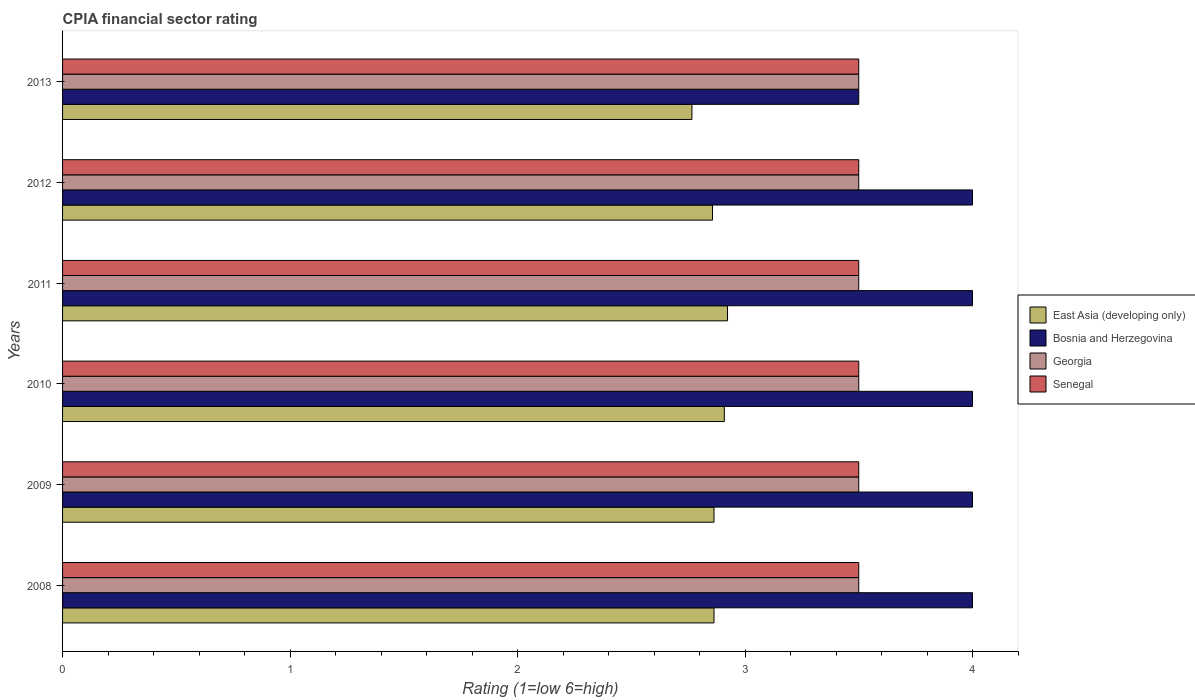How many different coloured bars are there?
Offer a terse response. 4. How many bars are there on the 1st tick from the top?
Your answer should be very brief. 4. How many bars are there on the 2nd tick from the bottom?
Make the answer very short. 4. What is the label of the 3rd group of bars from the top?
Provide a short and direct response. 2011. In how many cases, is the number of bars for a given year not equal to the number of legend labels?
Your response must be concise. 0. What is the CPIA rating in East Asia (developing only) in 2012?
Offer a very short reply. 2.86. Across all years, what is the maximum CPIA rating in Senegal?
Keep it short and to the point. 3.5. Across all years, what is the minimum CPIA rating in Senegal?
Ensure brevity in your answer.  3.5. In which year was the CPIA rating in Georgia maximum?
Provide a succinct answer. 2008. What is the difference between the CPIA rating in Senegal in 2008 and that in 2009?
Offer a very short reply. 0. What is the difference between the CPIA rating in Senegal in 2009 and the CPIA rating in Bosnia and Herzegovina in 2013?
Offer a very short reply. 0. In the year 2010, what is the difference between the CPIA rating in East Asia (developing only) and CPIA rating in Senegal?
Ensure brevity in your answer.  -0.59. What is the difference between the highest and the second highest CPIA rating in East Asia (developing only)?
Offer a terse response. 0.01. Is it the case that in every year, the sum of the CPIA rating in Bosnia and Herzegovina and CPIA rating in Georgia is greater than the sum of CPIA rating in East Asia (developing only) and CPIA rating in Senegal?
Give a very brief answer. No. What does the 1st bar from the top in 2008 represents?
Offer a very short reply. Senegal. What does the 2nd bar from the bottom in 2011 represents?
Your response must be concise. Bosnia and Herzegovina. Is it the case that in every year, the sum of the CPIA rating in Georgia and CPIA rating in Senegal is greater than the CPIA rating in East Asia (developing only)?
Keep it short and to the point. Yes. Are all the bars in the graph horizontal?
Offer a terse response. Yes. What is the difference between two consecutive major ticks on the X-axis?
Your response must be concise. 1. Does the graph contain grids?
Provide a succinct answer. No. Where does the legend appear in the graph?
Keep it short and to the point. Center right. How many legend labels are there?
Give a very brief answer. 4. How are the legend labels stacked?
Keep it short and to the point. Vertical. What is the title of the graph?
Make the answer very short. CPIA financial sector rating. Does "Afghanistan" appear as one of the legend labels in the graph?
Offer a terse response. No. What is the label or title of the Y-axis?
Your response must be concise. Years. What is the Rating (1=low 6=high) in East Asia (developing only) in 2008?
Offer a very short reply. 2.86. What is the Rating (1=low 6=high) in Bosnia and Herzegovina in 2008?
Give a very brief answer. 4. What is the Rating (1=low 6=high) of Georgia in 2008?
Offer a very short reply. 3.5. What is the Rating (1=low 6=high) of Senegal in 2008?
Keep it short and to the point. 3.5. What is the Rating (1=low 6=high) of East Asia (developing only) in 2009?
Offer a very short reply. 2.86. What is the Rating (1=low 6=high) in Georgia in 2009?
Offer a terse response. 3.5. What is the Rating (1=low 6=high) in East Asia (developing only) in 2010?
Ensure brevity in your answer.  2.91. What is the Rating (1=low 6=high) of Bosnia and Herzegovina in 2010?
Ensure brevity in your answer.  4. What is the Rating (1=low 6=high) in East Asia (developing only) in 2011?
Ensure brevity in your answer.  2.92. What is the Rating (1=low 6=high) of Georgia in 2011?
Keep it short and to the point. 3.5. What is the Rating (1=low 6=high) in East Asia (developing only) in 2012?
Give a very brief answer. 2.86. What is the Rating (1=low 6=high) of East Asia (developing only) in 2013?
Provide a short and direct response. 2.77. What is the Rating (1=low 6=high) of Senegal in 2013?
Provide a short and direct response. 3.5. Across all years, what is the maximum Rating (1=low 6=high) in East Asia (developing only)?
Your answer should be compact. 2.92. Across all years, what is the maximum Rating (1=low 6=high) in Senegal?
Make the answer very short. 3.5. Across all years, what is the minimum Rating (1=low 6=high) in East Asia (developing only)?
Make the answer very short. 2.77. Across all years, what is the minimum Rating (1=low 6=high) of Bosnia and Herzegovina?
Offer a terse response. 3.5. What is the total Rating (1=low 6=high) of East Asia (developing only) in the graph?
Make the answer very short. 17.18. What is the total Rating (1=low 6=high) of Bosnia and Herzegovina in the graph?
Your response must be concise. 23.5. What is the total Rating (1=low 6=high) in Senegal in the graph?
Give a very brief answer. 21. What is the difference between the Rating (1=low 6=high) of East Asia (developing only) in 2008 and that in 2009?
Ensure brevity in your answer.  0. What is the difference between the Rating (1=low 6=high) in Bosnia and Herzegovina in 2008 and that in 2009?
Your response must be concise. 0. What is the difference between the Rating (1=low 6=high) of Georgia in 2008 and that in 2009?
Keep it short and to the point. 0. What is the difference between the Rating (1=low 6=high) of Senegal in 2008 and that in 2009?
Your response must be concise. 0. What is the difference between the Rating (1=low 6=high) of East Asia (developing only) in 2008 and that in 2010?
Ensure brevity in your answer.  -0.05. What is the difference between the Rating (1=low 6=high) of Bosnia and Herzegovina in 2008 and that in 2010?
Make the answer very short. 0. What is the difference between the Rating (1=low 6=high) in East Asia (developing only) in 2008 and that in 2011?
Ensure brevity in your answer.  -0.06. What is the difference between the Rating (1=low 6=high) of Georgia in 2008 and that in 2011?
Your response must be concise. 0. What is the difference between the Rating (1=low 6=high) in East Asia (developing only) in 2008 and that in 2012?
Your answer should be very brief. 0.01. What is the difference between the Rating (1=low 6=high) of Bosnia and Herzegovina in 2008 and that in 2012?
Make the answer very short. 0. What is the difference between the Rating (1=low 6=high) in East Asia (developing only) in 2008 and that in 2013?
Your answer should be compact. 0.1. What is the difference between the Rating (1=low 6=high) of Bosnia and Herzegovina in 2008 and that in 2013?
Offer a terse response. 0.5. What is the difference between the Rating (1=low 6=high) in Senegal in 2008 and that in 2013?
Provide a short and direct response. 0. What is the difference between the Rating (1=low 6=high) in East Asia (developing only) in 2009 and that in 2010?
Offer a terse response. -0.05. What is the difference between the Rating (1=low 6=high) of Georgia in 2009 and that in 2010?
Ensure brevity in your answer.  0. What is the difference between the Rating (1=low 6=high) in Senegal in 2009 and that in 2010?
Your answer should be very brief. 0. What is the difference between the Rating (1=low 6=high) in East Asia (developing only) in 2009 and that in 2011?
Offer a terse response. -0.06. What is the difference between the Rating (1=low 6=high) in Georgia in 2009 and that in 2011?
Offer a very short reply. 0. What is the difference between the Rating (1=low 6=high) in Senegal in 2009 and that in 2011?
Your answer should be compact. 0. What is the difference between the Rating (1=low 6=high) in East Asia (developing only) in 2009 and that in 2012?
Keep it short and to the point. 0.01. What is the difference between the Rating (1=low 6=high) of Senegal in 2009 and that in 2012?
Make the answer very short. 0. What is the difference between the Rating (1=low 6=high) of East Asia (developing only) in 2009 and that in 2013?
Offer a very short reply. 0.1. What is the difference between the Rating (1=low 6=high) in Georgia in 2009 and that in 2013?
Keep it short and to the point. 0. What is the difference between the Rating (1=low 6=high) of Senegal in 2009 and that in 2013?
Provide a succinct answer. 0. What is the difference between the Rating (1=low 6=high) in East Asia (developing only) in 2010 and that in 2011?
Your answer should be very brief. -0.01. What is the difference between the Rating (1=low 6=high) in Georgia in 2010 and that in 2011?
Give a very brief answer. 0. What is the difference between the Rating (1=low 6=high) in Senegal in 2010 and that in 2011?
Provide a short and direct response. 0. What is the difference between the Rating (1=low 6=high) in East Asia (developing only) in 2010 and that in 2012?
Offer a terse response. 0.05. What is the difference between the Rating (1=low 6=high) in Bosnia and Herzegovina in 2010 and that in 2012?
Ensure brevity in your answer.  0. What is the difference between the Rating (1=low 6=high) of Georgia in 2010 and that in 2012?
Ensure brevity in your answer.  0. What is the difference between the Rating (1=low 6=high) of East Asia (developing only) in 2010 and that in 2013?
Offer a terse response. 0.14. What is the difference between the Rating (1=low 6=high) in Bosnia and Herzegovina in 2010 and that in 2013?
Your answer should be very brief. 0.5. What is the difference between the Rating (1=low 6=high) in Senegal in 2010 and that in 2013?
Offer a terse response. 0. What is the difference between the Rating (1=low 6=high) in East Asia (developing only) in 2011 and that in 2012?
Provide a succinct answer. 0.07. What is the difference between the Rating (1=low 6=high) in Bosnia and Herzegovina in 2011 and that in 2012?
Give a very brief answer. 0. What is the difference between the Rating (1=low 6=high) in Georgia in 2011 and that in 2012?
Your response must be concise. 0. What is the difference between the Rating (1=low 6=high) of Senegal in 2011 and that in 2012?
Provide a succinct answer. 0. What is the difference between the Rating (1=low 6=high) in East Asia (developing only) in 2011 and that in 2013?
Provide a short and direct response. 0.16. What is the difference between the Rating (1=low 6=high) of East Asia (developing only) in 2012 and that in 2013?
Ensure brevity in your answer.  0.09. What is the difference between the Rating (1=low 6=high) of East Asia (developing only) in 2008 and the Rating (1=low 6=high) of Bosnia and Herzegovina in 2009?
Give a very brief answer. -1.14. What is the difference between the Rating (1=low 6=high) in East Asia (developing only) in 2008 and the Rating (1=low 6=high) in Georgia in 2009?
Provide a short and direct response. -0.64. What is the difference between the Rating (1=low 6=high) in East Asia (developing only) in 2008 and the Rating (1=low 6=high) in Senegal in 2009?
Provide a short and direct response. -0.64. What is the difference between the Rating (1=low 6=high) in Bosnia and Herzegovina in 2008 and the Rating (1=low 6=high) in Georgia in 2009?
Make the answer very short. 0.5. What is the difference between the Rating (1=low 6=high) in Georgia in 2008 and the Rating (1=low 6=high) in Senegal in 2009?
Offer a terse response. 0. What is the difference between the Rating (1=low 6=high) of East Asia (developing only) in 2008 and the Rating (1=low 6=high) of Bosnia and Herzegovina in 2010?
Your answer should be very brief. -1.14. What is the difference between the Rating (1=low 6=high) of East Asia (developing only) in 2008 and the Rating (1=low 6=high) of Georgia in 2010?
Your answer should be compact. -0.64. What is the difference between the Rating (1=low 6=high) of East Asia (developing only) in 2008 and the Rating (1=low 6=high) of Senegal in 2010?
Provide a short and direct response. -0.64. What is the difference between the Rating (1=low 6=high) in Bosnia and Herzegovina in 2008 and the Rating (1=low 6=high) in Georgia in 2010?
Your answer should be compact. 0.5. What is the difference between the Rating (1=low 6=high) of East Asia (developing only) in 2008 and the Rating (1=low 6=high) of Bosnia and Herzegovina in 2011?
Keep it short and to the point. -1.14. What is the difference between the Rating (1=low 6=high) in East Asia (developing only) in 2008 and the Rating (1=low 6=high) in Georgia in 2011?
Provide a short and direct response. -0.64. What is the difference between the Rating (1=low 6=high) of East Asia (developing only) in 2008 and the Rating (1=low 6=high) of Senegal in 2011?
Your response must be concise. -0.64. What is the difference between the Rating (1=low 6=high) in Georgia in 2008 and the Rating (1=low 6=high) in Senegal in 2011?
Your answer should be compact. 0. What is the difference between the Rating (1=low 6=high) in East Asia (developing only) in 2008 and the Rating (1=low 6=high) in Bosnia and Herzegovina in 2012?
Provide a succinct answer. -1.14. What is the difference between the Rating (1=low 6=high) in East Asia (developing only) in 2008 and the Rating (1=low 6=high) in Georgia in 2012?
Your response must be concise. -0.64. What is the difference between the Rating (1=low 6=high) in East Asia (developing only) in 2008 and the Rating (1=low 6=high) in Senegal in 2012?
Your answer should be very brief. -0.64. What is the difference between the Rating (1=low 6=high) of Bosnia and Herzegovina in 2008 and the Rating (1=low 6=high) of Georgia in 2012?
Make the answer very short. 0.5. What is the difference between the Rating (1=low 6=high) in East Asia (developing only) in 2008 and the Rating (1=low 6=high) in Bosnia and Herzegovina in 2013?
Your response must be concise. -0.64. What is the difference between the Rating (1=low 6=high) of East Asia (developing only) in 2008 and the Rating (1=low 6=high) of Georgia in 2013?
Keep it short and to the point. -0.64. What is the difference between the Rating (1=low 6=high) in East Asia (developing only) in 2008 and the Rating (1=low 6=high) in Senegal in 2013?
Your answer should be very brief. -0.64. What is the difference between the Rating (1=low 6=high) of Georgia in 2008 and the Rating (1=low 6=high) of Senegal in 2013?
Give a very brief answer. 0. What is the difference between the Rating (1=low 6=high) in East Asia (developing only) in 2009 and the Rating (1=low 6=high) in Bosnia and Herzegovina in 2010?
Your answer should be compact. -1.14. What is the difference between the Rating (1=low 6=high) of East Asia (developing only) in 2009 and the Rating (1=low 6=high) of Georgia in 2010?
Provide a short and direct response. -0.64. What is the difference between the Rating (1=low 6=high) of East Asia (developing only) in 2009 and the Rating (1=low 6=high) of Senegal in 2010?
Give a very brief answer. -0.64. What is the difference between the Rating (1=low 6=high) in Bosnia and Herzegovina in 2009 and the Rating (1=low 6=high) in Georgia in 2010?
Keep it short and to the point. 0.5. What is the difference between the Rating (1=low 6=high) in Bosnia and Herzegovina in 2009 and the Rating (1=low 6=high) in Senegal in 2010?
Keep it short and to the point. 0.5. What is the difference between the Rating (1=low 6=high) of East Asia (developing only) in 2009 and the Rating (1=low 6=high) of Bosnia and Herzegovina in 2011?
Your answer should be very brief. -1.14. What is the difference between the Rating (1=low 6=high) in East Asia (developing only) in 2009 and the Rating (1=low 6=high) in Georgia in 2011?
Keep it short and to the point. -0.64. What is the difference between the Rating (1=low 6=high) of East Asia (developing only) in 2009 and the Rating (1=low 6=high) of Senegal in 2011?
Offer a very short reply. -0.64. What is the difference between the Rating (1=low 6=high) in Georgia in 2009 and the Rating (1=low 6=high) in Senegal in 2011?
Keep it short and to the point. 0. What is the difference between the Rating (1=low 6=high) in East Asia (developing only) in 2009 and the Rating (1=low 6=high) in Bosnia and Herzegovina in 2012?
Provide a succinct answer. -1.14. What is the difference between the Rating (1=low 6=high) in East Asia (developing only) in 2009 and the Rating (1=low 6=high) in Georgia in 2012?
Provide a short and direct response. -0.64. What is the difference between the Rating (1=low 6=high) in East Asia (developing only) in 2009 and the Rating (1=low 6=high) in Senegal in 2012?
Ensure brevity in your answer.  -0.64. What is the difference between the Rating (1=low 6=high) of Georgia in 2009 and the Rating (1=low 6=high) of Senegal in 2012?
Ensure brevity in your answer.  0. What is the difference between the Rating (1=low 6=high) of East Asia (developing only) in 2009 and the Rating (1=low 6=high) of Bosnia and Herzegovina in 2013?
Ensure brevity in your answer.  -0.64. What is the difference between the Rating (1=low 6=high) in East Asia (developing only) in 2009 and the Rating (1=low 6=high) in Georgia in 2013?
Your answer should be very brief. -0.64. What is the difference between the Rating (1=low 6=high) in East Asia (developing only) in 2009 and the Rating (1=low 6=high) in Senegal in 2013?
Keep it short and to the point. -0.64. What is the difference between the Rating (1=low 6=high) in Bosnia and Herzegovina in 2009 and the Rating (1=low 6=high) in Senegal in 2013?
Give a very brief answer. 0.5. What is the difference between the Rating (1=low 6=high) in East Asia (developing only) in 2010 and the Rating (1=low 6=high) in Bosnia and Herzegovina in 2011?
Your answer should be very brief. -1.09. What is the difference between the Rating (1=low 6=high) of East Asia (developing only) in 2010 and the Rating (1=low 6=high) of Georgia in 2011?
Provide a short and direct response. -0.59. What is the difference between the Rating (1=low 6=high) of East Asia (developing only) in 2010 and the Rating (1=low 6=high) of Senegal in 2011?
Keep it short and to the point. -0.59. What is the difference between the Rating (1=low 6=high) of Bosnia and Herzegovina in 2010 and the Rating (1=low 6=high) of Georgia in 2011?
Offer a very short reply. 0.5. What is the difference between the Rating (1=low 6=high) of Georgia in 2010 and the Rating (1=low 6=high) of Senegal in 2011?
Ensure brevity in your answer.  0. What is the difference between the Rating (1=low 6=high) of East Asia (developing only) in 2010 and the Rating (1=low 6=high) of Bosnia and Herzegovina in 2012?
Your answer should be compact. -1.09. What is the difference between the Rating (1=low 6=high) in East Asia (developing only) in 2010 and the Rating (1=low 6=high) in Georgia in 2012?
Make the answer very short. -0.59. What is the difference between the Rating (1=low 6=high) in East Asia (developing only) in 2010 and the Rating (1=low 6=high) in Senegal in 2012?
Provide a succinct answer. -0.59. What is the difference between the Rating (1=low 6=high) of Georgia in 2010 and the Rating (1=low 6=high) of Senegal in 2012?
Offer a very short reply. 0. What is the difference between the Rating (1=low 6=high) in East Asia (developing only) in 2010 and the Rating (1=low 6=high) in Bosnia and Herzegovina in 2013?
Ensure brevity in your answer.  -0.59. What is the difference between the Rating (1=low 6=high) in East Asia (developing only) in 2010 and the Rating (1=low 6=high) in Georgia in 2013?
Keep it short and to the point. -0.59. What is the difference between the Rating (1=low 6=high) of East Asia (developing only) in 2010 and the Rating (1=low 6=high) of Senegal in 2013?
Offer a terse response. -0.59. What is the difference between the Rating (1=low 6=high) of Bosnia and Herzegovina in 2010 and the Rating (1=low 6=high) of Georgia in 2013?
Offer a terse response. 0.5. What is the difference between the Rating (1=low 6=high) in Bosnia and Herzegovina in 2010 and the Rating (1=low 6=high) in Senegal in 2013?
Offer a terse response. 0.5. What is the difference between the Rating (1=low 6=high) in East Asia (developing only) in 2011 and the Rating (1=low 6=high) in Bosnia and Herzegovina in 2012?
Keep it short and to the point. -1.08. What is the difference between the Rating (1=low 6=high) of East Asia (developing only) in 2011 and the Rating (1=low 6=high) of Georgia in 2012?
Offer a terse response. -0.58. What is the difference between the Rating (1=low 6=high) in East Asia (developing only) in 2011 and the Rating (1=low 6=high) in Senegal in 2012?
Provide a succinct answer. -0.58. What is the difference between the Rating (1=low 6=high) of Bosnia and Herzegovina in 2011 and the Rating (1=low 6=high) of Georgia in 2012?
Your response must be concise. 0.5. What is the difference between the Rating (1=low 6=high) of Bosnia and Herzegovina in 2011 and the Rating (1=low 6=high) of Senegal in 2012?
Your answer should be compact. 0.5. What is the difference between the Rating (1=low 6=high) of East Asia (developing only) in 2011 and the Rating (1=low 6=high) of Bosnia and Herzegovina in 2013?
Offer a very short reply. -0.58. What is the difference between the Rating (1=low 6=high) of East Asia (developing only) in 2011 and the Rating (1=low 6=high) of Georgia in 2013?
Your answer should be compact. -0.58. What is the difference between the Rating (1=low 6=high) of East Asia (developing only) in 2011 and the Rating (1=low 6=high) of Senegal in 2013?
Give a very brief answer. -0.58. What is the difference between the Rating (1=low 6=high) in Bosnia and Herzegovina in 2011 and the Rating (1=low 6=high) in Georgia in 2013?
Provide a succinct answer. 0.5. What is the difference between the Rating (1=low 6=high) in Georgia in 2011 and the Rating (1=low 6=high) in Senegal in 2013?
Keep it short and to the point. 0. What is the difference between the Rating (1=low 6=high) of East Asia (developing only) in 2012 and the Rating (1=low 6=high) of Bosnia and Herzegovina in 2013?
Keep it short and to the point. -0.64. What is the difference between the Rating (1=low 6=high) in East Asia (developing only) in 2012 and the Rating (1=low 6=high) in Georgia in 2013?
Offer a very short reply. -0.64. What is the difference between the Rating (1=low 6=high) of East Asia (developing only) in 2012 and the Rating (1=low 6=high) of Senegal in 2013?
Your answer should be very brief. -0.64. What is the average Rating (1=low 6=high) in East Asia (developing only) per year?
Give a very brief answer. 2.86. What is the average Rating (1=low 6=high) in Bosnia and Herzegovina per year?
Provide a short and direct response. 3.92. In the year 2008, what is the difference between the Rating (1=low 6=high) in East Asia (developing only) and Rating (1=low 6=high) in Bosnia and Herzegovina?
Ensure brevity in your answer.  -1.14. In the year 2008, what is the difference between the Rating (1=low 6=high) in East Asia (developing only) and Rating (1=low 6=high) in Georgia?
Make the answer very short. -0.64. In the year 2008, what is the difference between the Rating (1=low 6=high) in East Asia (developing only) and Rating (1=low 6=high) in Senegal?
Give a very brief answer. -0.64. In the year 2009, what is the difference between the Rating (1=low 6=high) of East Asia (developing only) and Rating (1=low 6=high) of Bosnia and Herzegovina?
Provide a succinct answer. -1.14. In the year 2009, what is the difference between the Rating (1=low 6=high) of East Asia (developing only) and Rating (1=low 6=high) of Georgia?
Offer a very short reply. -0.64. In the year 2009, what is the difference between the Rating (1=low 6=high) of East Asia (developing only) and Rating (1=low 6=high) of Senegal?
Keep it short and to the point. -0.64. In the year 2009, what is the difference between the Rating (1=low 6=high) of Bosnia and Herzegovina and Rating (1=low 6=high) of Georgia?
Keep it short and to the point. 0.5. In the year 2009, what is the difference between the Rating (1=low 6=high) of Bosnia and Herzegovina and Rating (1=low 6=high) of Senegal?
Offer a very short reply. 0.5. In the year 2010, what is the difference between the Rating (1=low 6=high) of East Asia (developing only) and Rating (1=low 6=high) of Bosnia and Herzegovina?
Provide a short and direct response. -1.09. In the year 2010, what is the difference between the Rating (1=low 6=high) in East Asia (developing only) and Rating (1=low 6=high) in Georgia?
Make the answer very short. -0.59. In the year 2010, what is the difference between the Rating (1=low 6=high) of East Asia (developing only) and Rating (1=low 6=high) of Senegal?
Your response must be concise. -0.59. In the year 2010, what is the difference between the Rating (1=low 6=high) in Georgia and Rating (1=low 6=high) in Senegal?
Keep it short and to the point. 0. In the year 2011, what is the difference between the Rating (1=low 6=high) in East Asia (developing only) and Rating (1=low 6=high) in Bosnia and Herzegovina?
Keep it short and to the point. -1.08. In the year 2011, what is the difference between the Rating (1=low 6=high) in East Asia (developing only) and Rating (1=low 6=high) in Georgia?
Offer a very short reply. -0.58. In the year 2011, what is the difference between the Rating (1=low 6=high) of East Asia (developing only) and Rating (1=low 6=high) of Senegal?
Provide a short and direct response. -0.58. In the year 2011, what is the difference between the Rating (1=low 6=high) of Bosnia and Herzegovina and Rating (1=low 6=high) of Senegal?
Your answer should be compact. 0.5. In the year 2012, what is the difference between the Rating (1=low 6=high) in East Asia (developing only) and Rating (1=low 6=high) in Bosnia and Herzegovina?
Ensure brevity in your answer.  -1.14. In the year 2012, what is the difference between the Rating (1=low 6=high) of East Asia (developing only) and Rating (1=low 6=high) of Georgia?
Give a very brief answer. -0.64. In the year 2012, what is the difference between the Rating (1=low 6=high) of East Asia (developing only) and Rating (1=low 6=high) of Senegal?
Give a very brief answer. -0.64. In the year 2012, what is the difference between the Rating (1=low 6=high) in Bosnia and Herzegovina and Rating (1=low 6=high) in Georgia?
Make the answer very short. 0.5. In the year 2013, what is the difference between the Rating (1=low 6=high) of East Asia (developing only) and Rating (1=low 6=high) of Bosnia and Herzegovina?
Keep it short and to the point. -0.73. In the year 2013, what is the difference between the Rating (1=low 6=high) in East Asia (developing only) and Rating (1=low 6=high) in Georgia?
Offer a terse response. -0.73. In the year 2013, what is the difference between the Rating (1=low 6=high) of East Asia (developing only) and Rating (1=low 6=high) of Senegal?
Your response must be concise. -0.73. In the year 2013, what is the difference between the Rating (1=low 6=high) in Bosnia and Herzegovina and Rating (1=low 6=high) in Georgia?
Your response must be concise. 0. In the year 2013, what is the difference between the Rating (1=low 6=high) of Bosnia and Herzegovina and Rating (1=low 6=high) of Senegal?
Make the answer very short. 0. What is the ratio of the Rating (1=low 6=high) in Bosnia and Herzegovina in 2008 to that in 2009?
Offer a very short reply. 1. What is the ratio of the Rating (1=low 6=high) of Georgia in 2008 to that in 2009?
Your response must be concise. 1. What is the ratio of the Rating (1=low 6=high) in East Asia (developing only) in 2008 to that in 2010?
Offer a very short reply. 0.98. What is the ratio of the Rating (1=low 6=high) of Bosnia and Herzegovina in 2008 to that in 2010?
Your answer should be very brief. 1. What is the ratio of the Rating (1=low 6=high) in Georgia in 2008 to that in 2010?
Provide a succinct answer. 1. What is the ratio of the Rating (1=low 6=high) in Senegal in 2008 to that in 2010?
Provide a succinct answer. 1. What is the ratio of the Rating (1=low 6=high) of East Asia (developing only) in 2008 to that in 2011?
Your response must be concise. 0.98. What is the ratio of the Rating (1=low 6=high) of Bosnia and Herzegovina in 2008 to that in 2011?
Your answer should be very brief. 1. What is the ratio of the Rating (1=low 6=high) of East Asia (developing only) in 2008 to that in 2012?
Make the answer very short. 1. What is the ratio of the Rating (1=low 6=high) of Bosnia and Herzegovina in 2008 to that in 2012?
Make the answer very short. 1. What is the ratio of the Rating (1=low 6=high) of Georgia in 2008 to that in 2012?
Offer a terse response. 1. What is the ratio of the Rating (1=low 6=high) of East Asia (developing only) in 2008 to that in 2013?
Your answer should be compact. 1.03. What is the ratio of the Rating (1=low 6=high) of East Asia (developing only) in 2009 to that in 2010?
Provide a succinct answer. 0.98. What is the ratio of the Rating (1=low 6=high) in Bosnia and Herzegovina in 2009 to that in 2010?
Make the answer very short. 1. What is the ratio of the Rating (1=low 6=high) of Georgia in 2009 to that in 2010?
Give a very brief answer. 1. What is the ratio of the Rating (1=low 6=high) in Senegal in 2009 to that in 2010?
Make the answer very short. 1. What is the ratio of the Rating (1=low 6=high) of East Asia (developing only) in 2009 to that in 2011?
Offer a very short reply. 0.98. What is the ratio of the Rating (1=low 6=high) in Bosnia and Herzegovina in 2009 to that in 2012?
Offer a very short reply. 1. What is the ratio of the Rating (1=low 6=high) in East Asia (developing only) in 2009 to that in 2013?
Provide a succinct answer. 1.03. What is the ratio of the Rating (1=low 6=high) in Bosnia and Herzegovina in 2009 to that in 2013?
Provide a short and direct response. 1.14. What is the ratio of the Rating (1=low 6=high) in Georgia in 2009 to that in 2013?
Offer a very short reply. 1. What is the ratio of the Rating (1=low 6=high) of Senegal in 2009 to that in 2013?
Offer a terse response. 1. What is the ratio of the Rating (1=low 6=high) of East Asia (developing only) in 2010 to that in 2011?
Keep it short and to the point. 1. What is the ratio of the Rating (1=low 6=high) of East Asia (developing only) in 2010 to that in 2012?
Make the answer very short. 1.02. What is the ratio of the Rating (1=low 6=high) of Bosnia and Herzegovina in 2010 to that in 2012?
Keep it short and to the point. 1. What is the ratio of the Rating (1=low 6=high) of East Asia (developing only) in 2010 to that in 2013?
Your answer should be very brief. 1.05. What is the ratio of the Rating (1=low 6=high) of Georgia in 2010 to that in 2013?
Provide a short and direct response. 1. What is the ratio of the Rating (1=low 6=high) in East Asia (developing only) in 2011 to that in 2012?
Your answer should be very brief. 1.02. What is the ratio of the Rating (1=low 6=high) of Bosnia and Herzegovina in 2011 to that in 2012?
Keep it short and to the point. 1. What is the ratio of the Rating (1=low 6=high) in Georgia in 2011 to that in 2012?
Ensure brevity in your answer.  1. What is the ratio of the Rating (1=low 6=high) in East Asia (developing only) in 2011 to that in 2013?
Provide a succinct answer. 1.06. What is the ratio of the Rating (1=low 6=high) of Senegal in 2011 to that in 2013?
Provide a short and direct response. 1. What is the ratio of the Rating (1=low 6=high) of East Asia (developing only) in 2012 to that in 2013?
Provide a short and direct response. 1.03. What is the ratio of the Rating (1=low 6=high) in Georgia in 2012 to that in 2013?
Keep it short and to the point. 1. What is the difference between the highest and the second highest Rating (1=low 6=high) of East Asia (developing only)?
Make the answer very short. 0.01. What is the difference between the highest and the second highest Rating (1=low 6=high) in Bosnia and Herzegovina?
Make the answer very short. 0. What is the difference between the highest and the second highest Rating (1=low 6=high) in Georgia?
Make the answer very short. 0. What is the difference between the highest and the lowest Rating (1=low 6=high) in East Asia (developing only)?
Offer a terse response. 0.16. What is the difference between the highest and the lowest Rating (1=low 6=high) of Bosnia and Herzegovina?
Make the answer very short. 0.5. What is the difference between the highest and the lowest Rating (1=low 6=high) of Georgia?
Offer a very short reply. 0. 